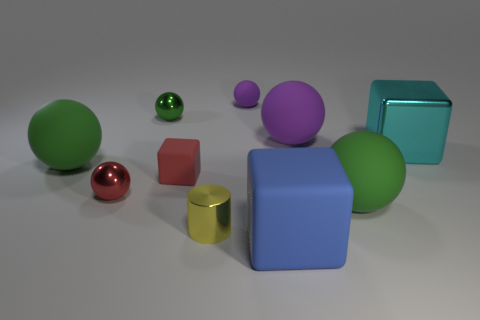Subtract all blocks. How many objects are left? 7 Subtract 1 cylinders. How many cylinders are left? 0 Subtract all red balls. How many balls are left? 5 Subtract all large cubes. How many cubes are left? 1 Subtract 0 yellow blocks. How many objects are left? 10 Subtract all gray cubes. Subtract all purple balls. How many cubes are left? 3 Subtract all cyan spheres. How many gray blocks are left? 0 Subtract all big green matte balls. Subtract all tiny green spheres. How many objects are left? 7 Add 3 spheres. How many spheres are left? 9 Add 1 purple matte things. How many purple matte things exist? 3 